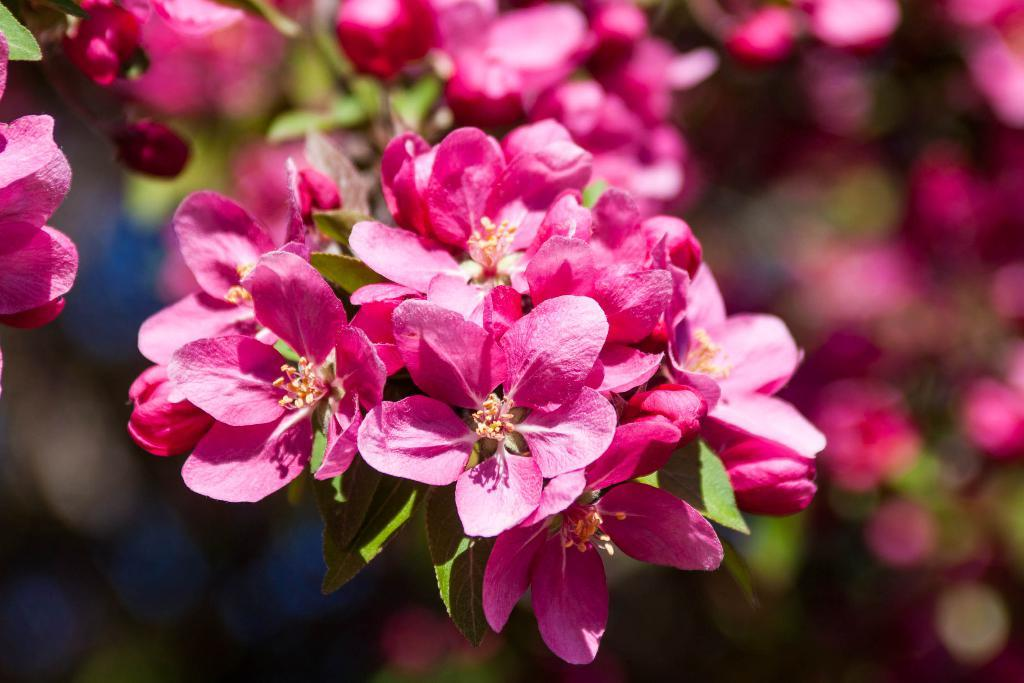What is the main subject of the image? The main subject of the image is flowers. Can you describe the flowers in the image? The flowers are pink in color. Are there any other elements associated with the flowers in the image? Yes, there are leaves associated with the flowers. What type of agreement is being signed by the cow in the image? There is no cow present in the image, and therefore no agreement being signed. 